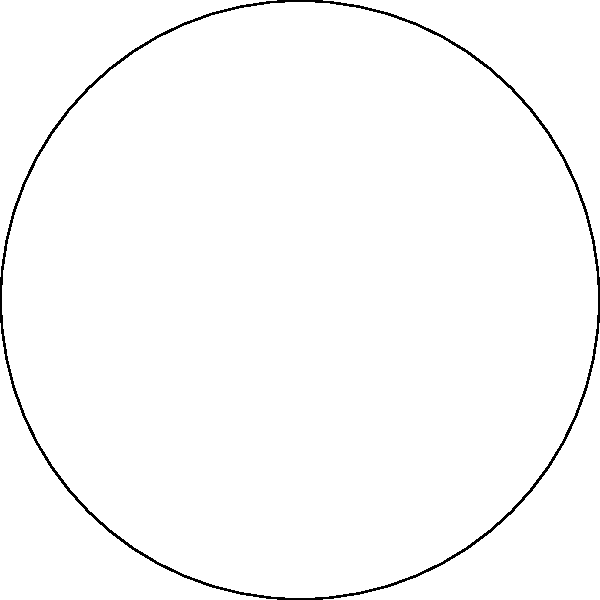As a former police officer, you've dealt with parallel lines on the road. Now, imagine you're on a hyperbolic plane where parallel lines behave differently. In the Poincaré disk model shown, lines AB and CD are parallel. What's the most surprising difference between these parallel lines and the ones you encountered on regular roads? Let's break this down step-by-step:

1. In Euclidean geometry (like on regular roads):
   - Parallel lines maintain a constant distance from each other.
   - Parallel lines never intersect, no matter how far they're extended.

2. In hyperbolic geometry (as shown in the Poincaré disk model):
   - Parallel lines appear to diverge from each other.
   - They still never intersect within the hyperbolic plane.

3. Key differences in the hyperbolic plane:
   a) The lines AB and CD are curved, not straight.
   b) They appear to bend away from each other.
   c) If extended, they would meet at the boundary of the disk (which represents infinity in this model).

4. The most surprising difference:
   In hyperbolic geometry, there are infinitely many lines parallel to a given line through a point not on that line. This is in stark contrast to Euclidean geometry, where only one such parallel line exists.

5. In the context of the question:
   If you were driving on a "hyperbolic road," you'd notice that parallel lanes would appear to curve away from each other, even though they never actually intersect within the plane.

The most surprising aspect for someone used to Euclidean geometry (like roads in the real world) would be that these parallel lines diverge from each other, rather than remaining a constant distance apart.
Answer: Parallel lines diverge instead of remaining equidistant. 